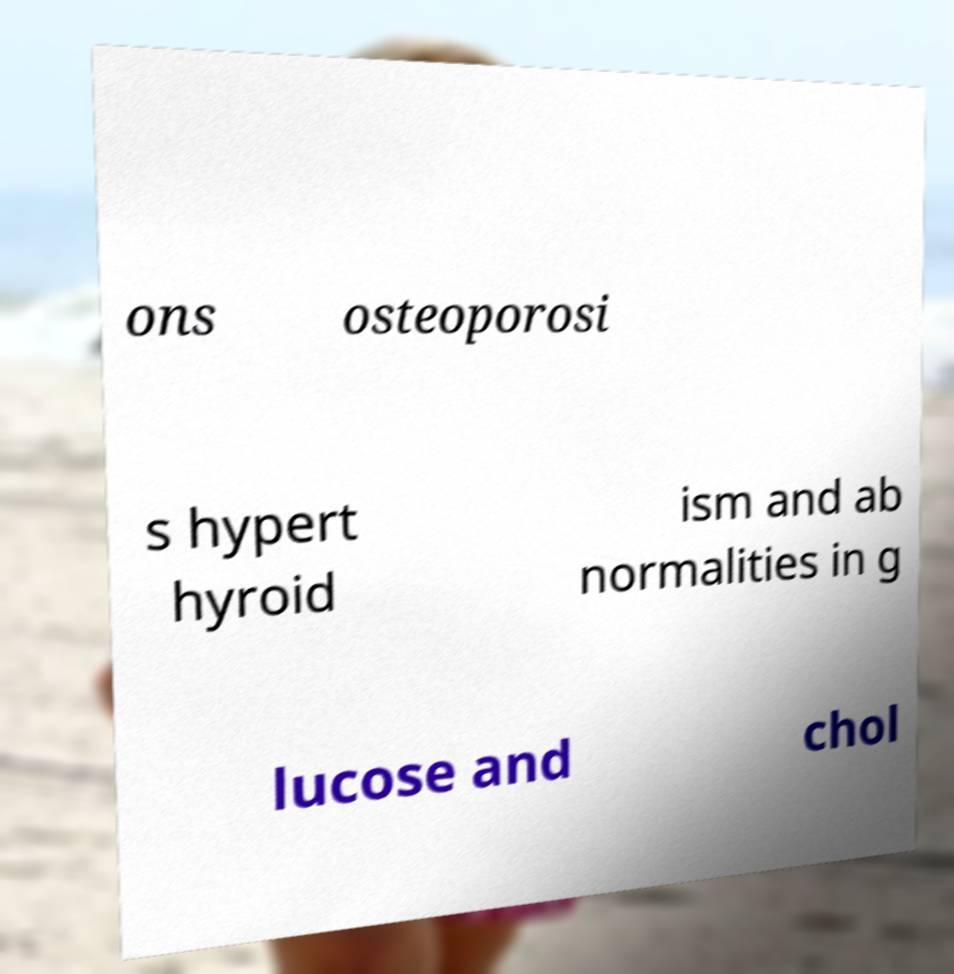For documentation purposes, I need the text within this image transcribed. Could you provide that? ons osteoporosi s hypert hyroid ism and ab normalities in g lucose and chol 